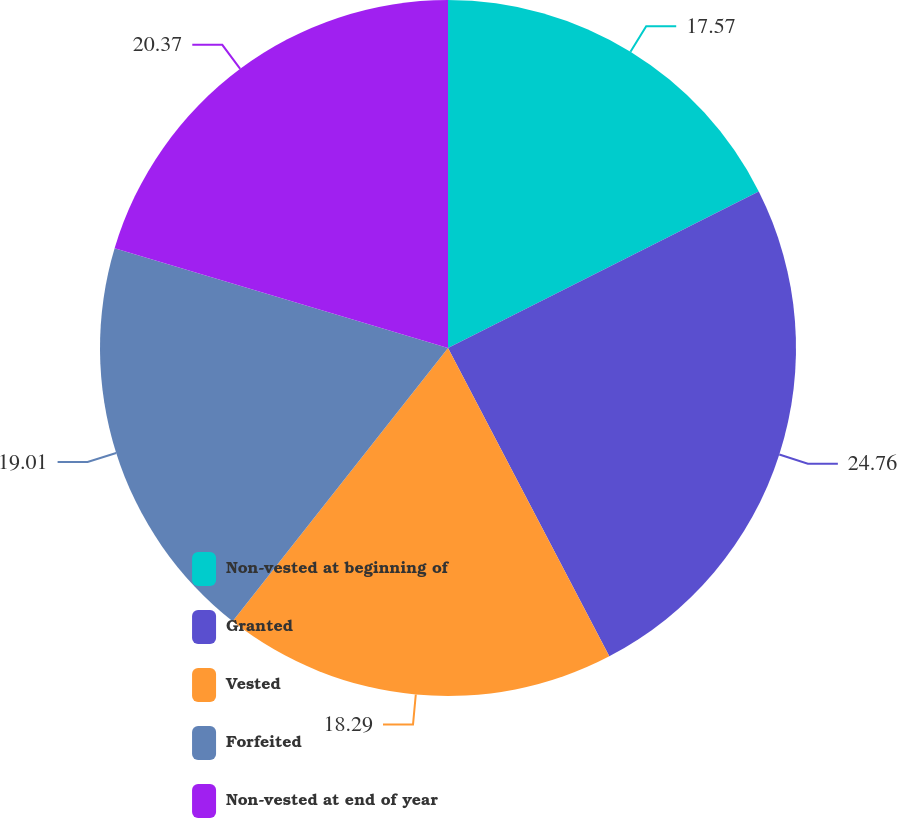Convert chart to OTSL. <chart><loc_0><loc_0><loc_500><loc_500><pie_chart><fcel>Non-vested at beginning of<fcel>Granted<fcel>Vested<fcel>Forfeited<fcel>Non-vested at end of year<nl><fcel>17.57%<fcel>24.76%<fcel>18.29%<fcel>19.01%<fcel>20.37%<nl></chart> 